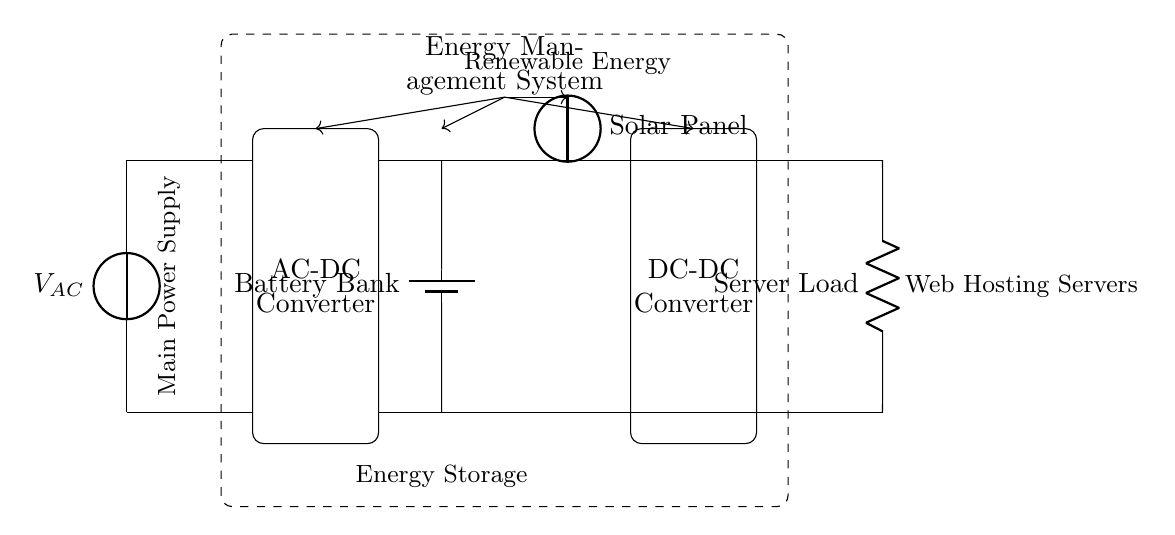What is the type of the main power supply? The main power supply is an alternating current (AC) source, which is identified as the voltage source in the circuit diagram labeled "V_AC".
Answer: AC What component is used for energy storage? The energy storage component is a battery bank, which is labeled in the circuit as "Battery Bank".
Answer: Battery Bank How many converters are present in the system? There are two converters: an AC-DC converter and a DC-DC converter. The AC-DC converter is shown on the left side, and the DC-DC converter is on the right side, both indicated by their respective labels.
Answer: 2 What provides renewable energy to the system? Renewable energy is supplied by the solar panel, which is represented as a voltage source labeled "Solar Panel" in the circuit diagram.
Answer: Solar Panel What is the load in this circuit? The load is represented as a resistor labeled "Server Load" and is connected to the output of the DC-DC converter in the circuit diagram.
Answer: Server Load How does the energy management system interact with the components? The energy management system coordinates with the battery bank, solar panel, AC-DC converter, and DC-DC converter, as indicated by the arrows showing control lines from the energy management system to these components.
Answer: Control lines What type of power does the server load require? The server load requires direct current (DC) power, as it is connected to the output of the DC-DC converter, which converts the DC from the battery bank and solar panel to the required voltage level.
Answer: DC 